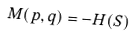Convert formula to latex. <formula><loc_0><loc_0><loc_500><loc_500>M ( p , q ) = - H ( S )</formula> 